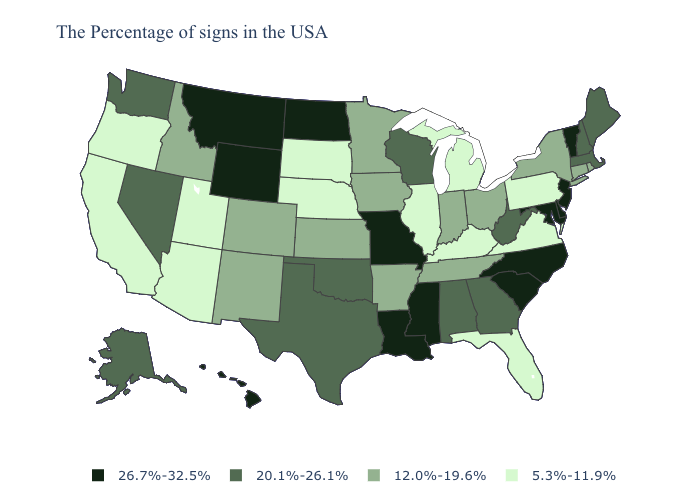Does Rhode Island have the same value as Tennessee?
Short answer required. Yes. Name the states that have a value in the range 26.7%-32.5%?
Short answer required. Vermont, New Jersey, Delaware, Maryland, North Carolina, South Carolina, Mississippi, Louisiana, Missouri, North Dakota, Wyoming, Montana, Hawaii. What is the highest value in the MidWest ?
Answer briefly. 26.7%-32.5%. Does New Jersey have the highest value in the USA?
Short answer required. Yes. Name the states that have a value in the range 12.0%-19.6%?
Keep it brief. Rhode Island, Connecticut, New York, Ohio, Indiana, Tennessee, Arkansas, Minnesota, Iowa, Kansas, Colorado, New Mexico, Idaho. Does Indiana have a lower value than Alabama?
Give a very brief answer. Yes. Among the states that border Oregon , does Idaho have the lowest value?
Answer briefly. No. What is the value of Illinois?
Be succinct. 5.3%-11.9%. What is the lowest value in the USA?
Concise answer only. 5.3%-11.9%. How many symbols are there in the legend?
Concise answer only. 4. Is the legend a continuous bar?
Write a very short answer. No. What is the lowest value in the West?
Quick response, please. 5.3%-11.9%. Name the states that have a value in the range 5.3%-11.9%?
Quick response, please. Pennsylvania, Virginia, Florida, Michigan, Kentucky, Illinois, Nebraska, South Dakota, Utah, Arizona, California, Oregon. What is the value of Tennessee?
Write a very short answer. 12.0%-19.6%. Does the first symbol in the legend represent the smallest category?
Quick response, please. No. 